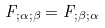Convert formula to latex. <formula><loc_0><loc_0><loc_500><loc_500>F _ { ; \alpha ; \beta } = F _ { ; \beta ; \alpha }</formula> 